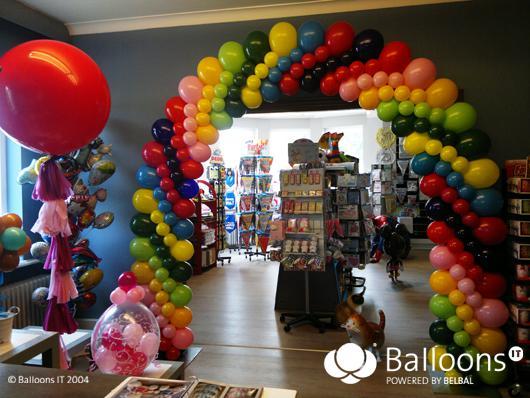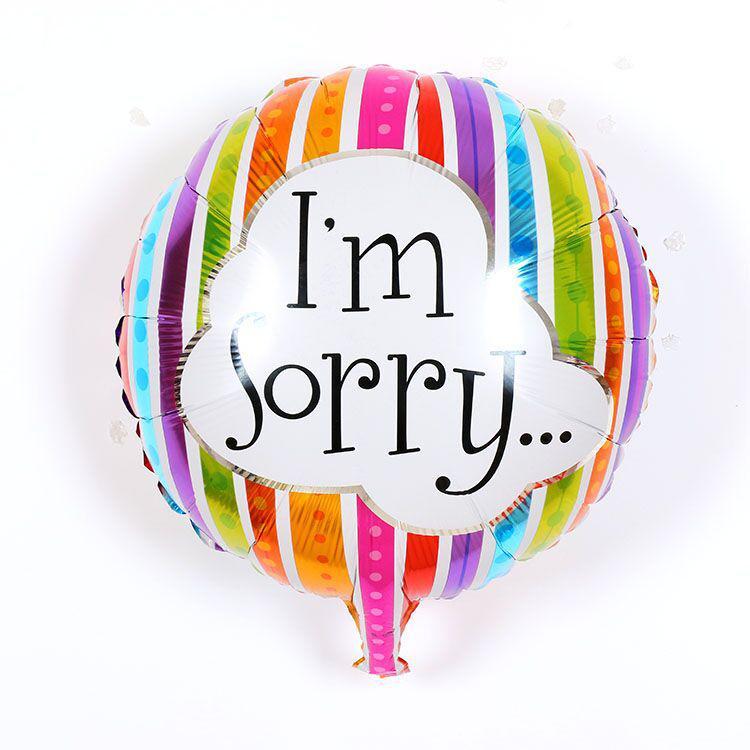The first image is the image on the left, the second image is the image on the right. Examine the images to the left and right. Is the description "There is a single balloon in the left image." accurate? Answer yes or no. No. The first image is the image on the left, the second image is the image on the right. Analyze the images presented: Is the assertion "There are no more than seven balloons with at least one looking like a piece of wrapped candy." valid? Answer yes or no. No. 